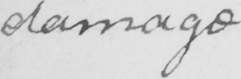What text is written in this handwritten line? damage 